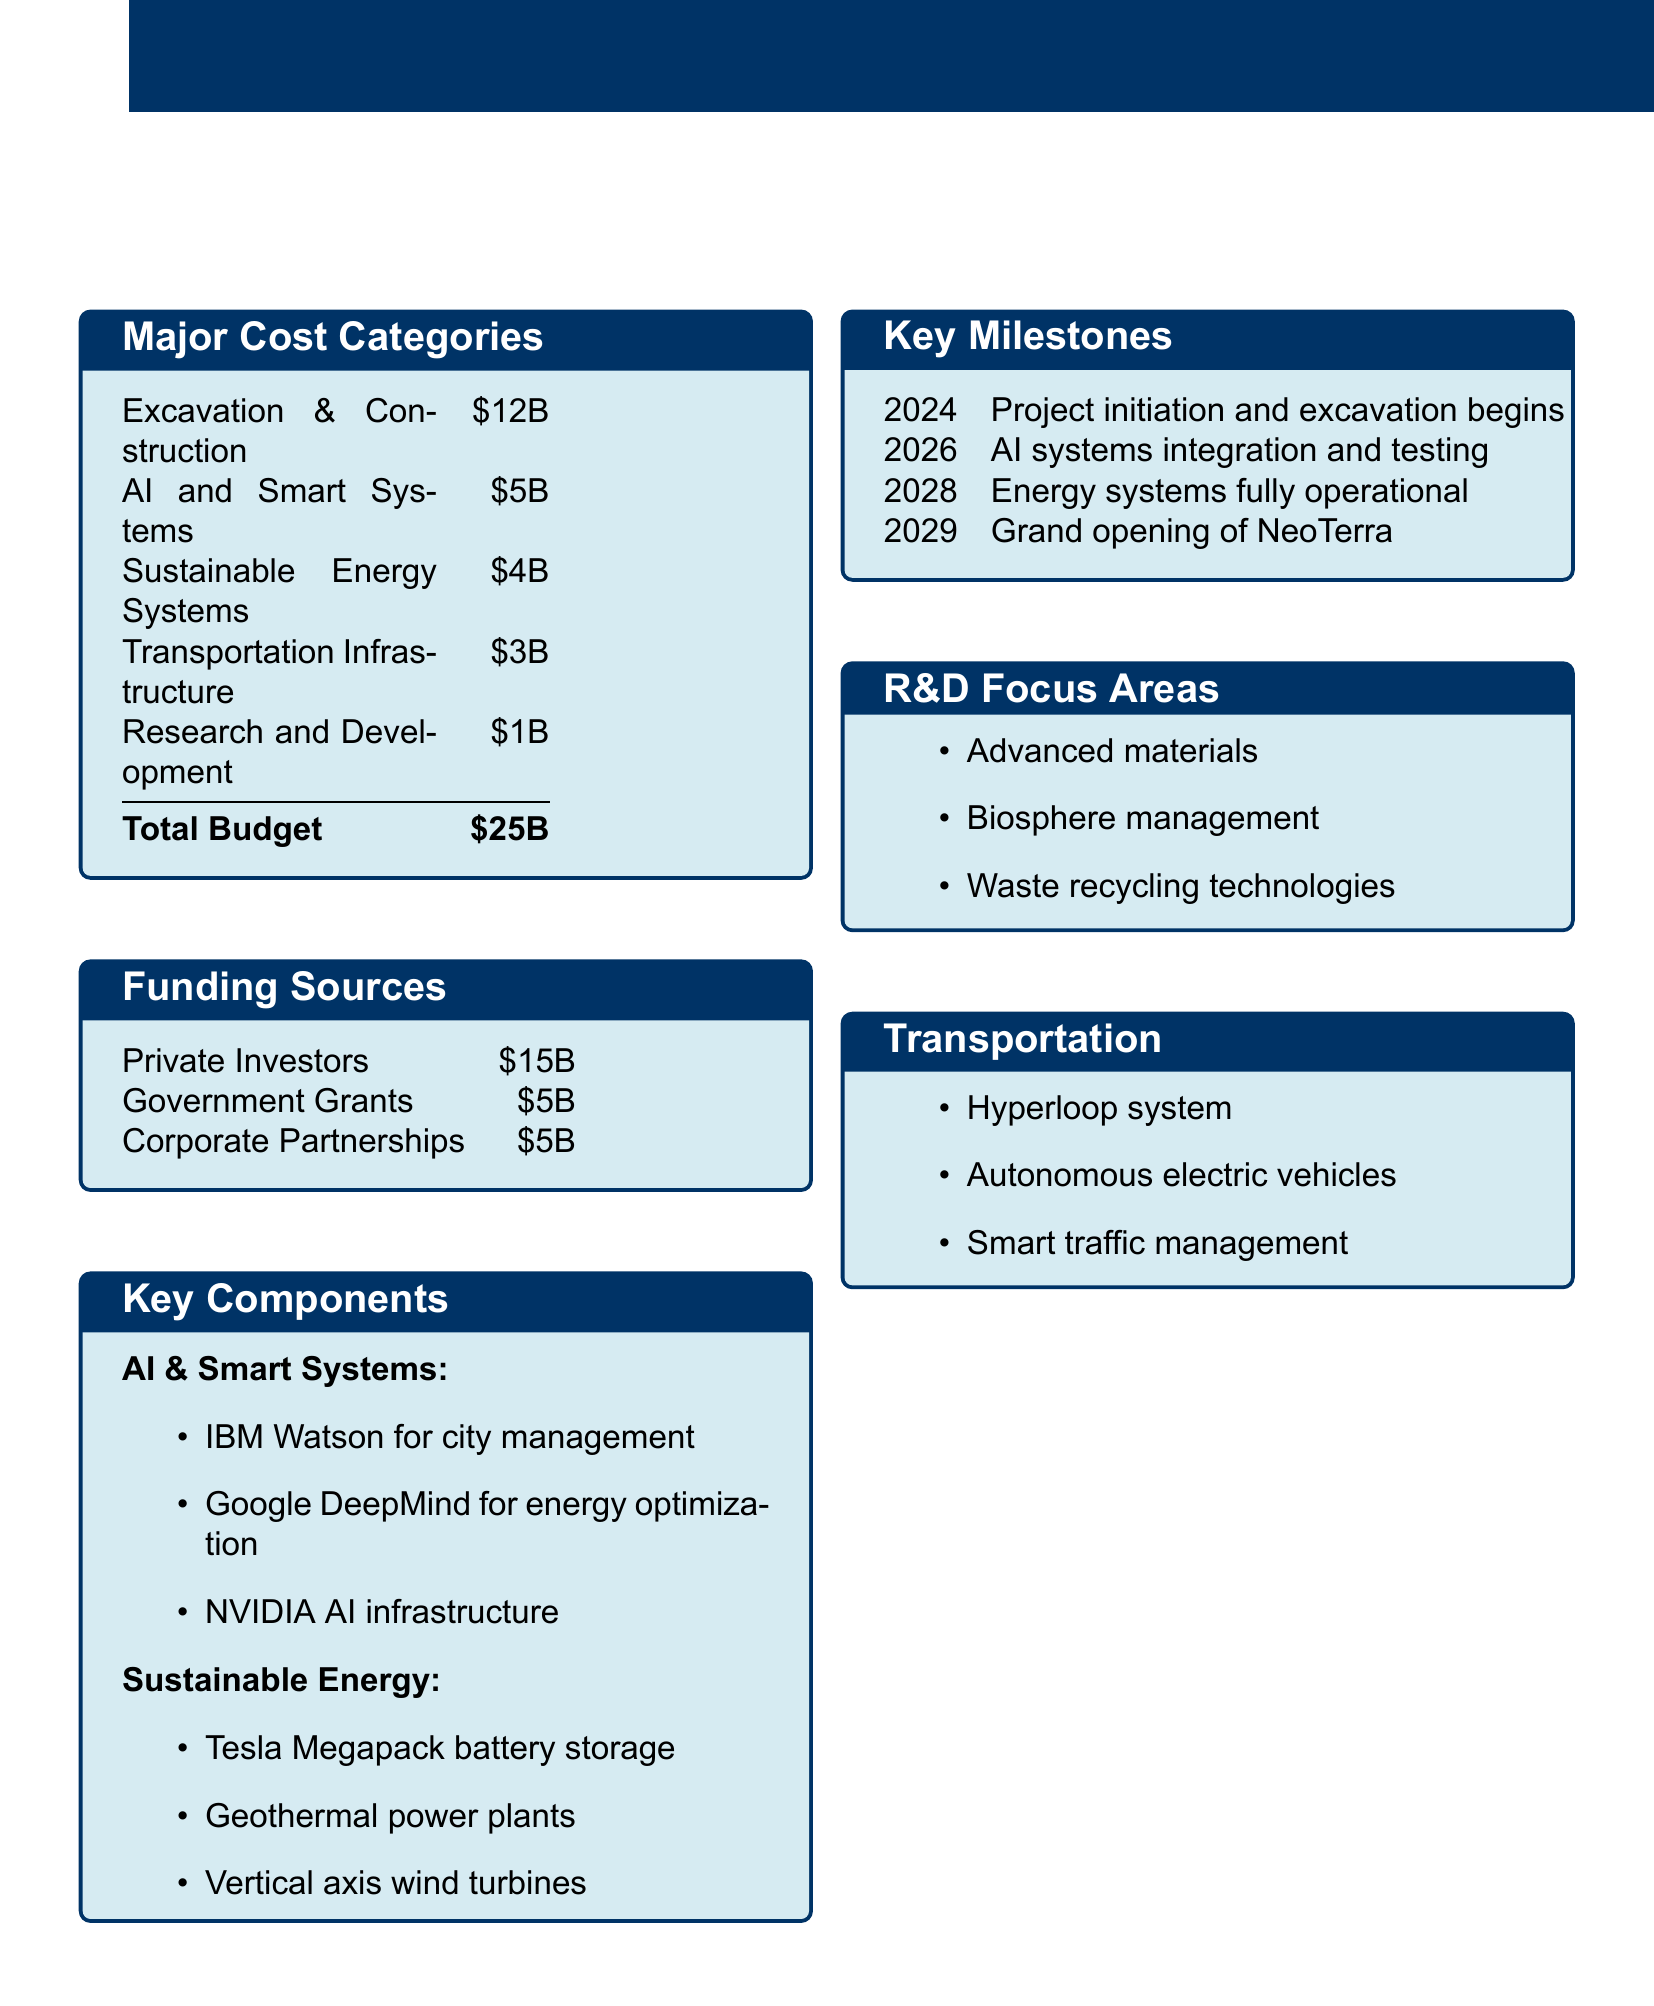what is the total budget? The total budget is the sum of all major cost categories listed, which amounts to $25 billion.
Answer: $25B what is the cost for AI and Smart Systems? The cost for AI and Smart Systems is specified in the major cost categories table.
Answer: $5B which year marks the grand opening of NeoTerra? The grand opening year of NeoTerra is listed in the key milestones section.
Answer: 2029 how much funding is expected from private investors? The expected funding from private investors is indicated in the funding sources table.
Answer: $15B what are the key focus areas for R&D? The key focus areas for R&D are detailed in the R&D focus areas section.
Answer: Advanced materials, Biosphere management, Waste recycling technologies what kind of transportation systems are being developed? The transportation systems being developed are outlined in the transportation section of the document.
Answer: Hyperloop system, Autonomous electric vehicles, Smart traffic management what is the total funding from government grants and corporate partnerships combined? The total funding from the two sources can be calculated by adding government grants and corporate partnerships listed in the funding sources.
Answer: $10B which technology is mentioned for energy optimization? The technology mentioned for energy optimization is stated in the AI & Smart Systems section.
Answer: Google DeepMind 